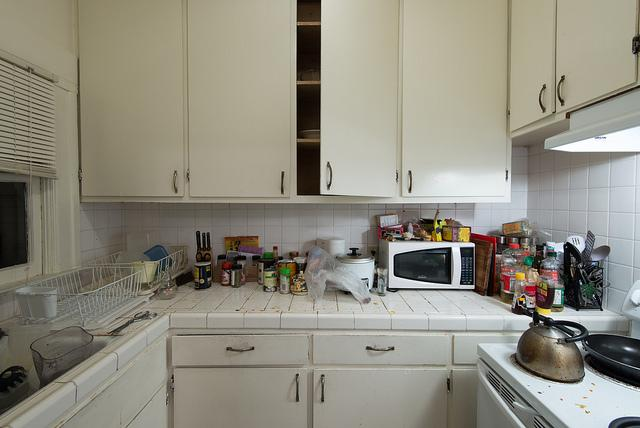What are the two rectangular baskets on the left counter for?

Choices:
A) rinse dishes
B) fruits
C) decorations
D) dish draining dish draining 